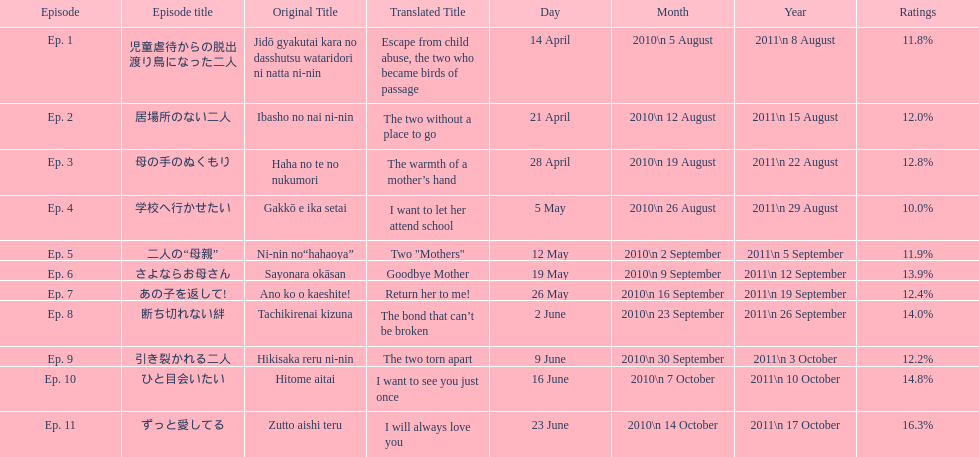Which episode was titled i want to let her attend school? Ep. 4. 